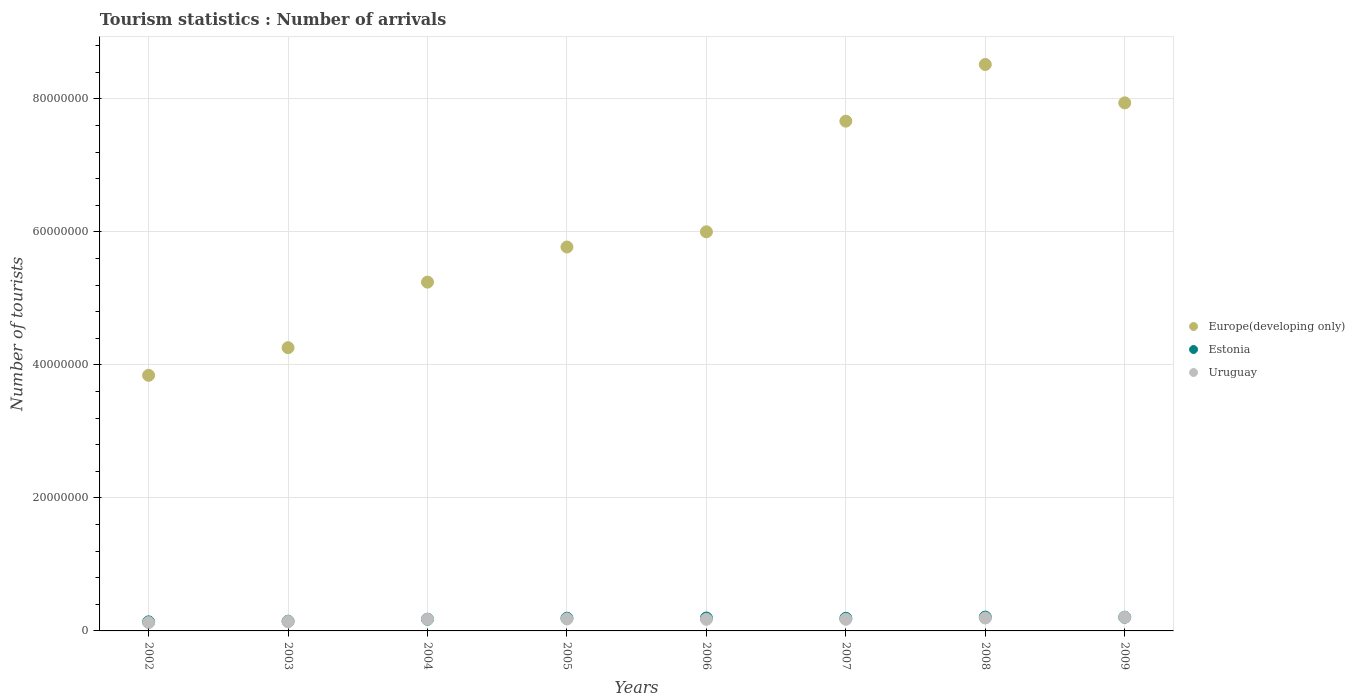Is the number of dotlines equal to the number of legend labels?
Give a very brief answer. Yes. What is the number of tourist arrivals in Estonia in 2003?
Ensure brevity in your answer.  1.46e+06. Across all years, what is the maximum number of tourist arrivals in Uruguay?
Offer a very short reply. 2.06e+06. Across all years, what is the minimum number of tourist arrivals in Europe(developing only)?
Your answer should be very brief. 3.84e+07. What is the total number of tourist arrivals in Europe(developing only) in the graph?
Your answer should be very brief. 4.92e+08. What is the difference between the number of tourist arrivals in Uruguay in 2002 and that in 2009?
Offer a terse response. -7.97e+05. What is the difference between the number of tourist arrivals in Estonia in 2004 and the number of tourist arrivals in Europe(developing only) in 2003?
Keep it short and to the point. -4.08e+07. What is the average number of tourist arrivals in Europe(developing only) per year?
Provide a succinct answer. 6.16e+07. In the year 2006, what is the difference between the number of tourist arrivals in Europe(developing only) and number of tourist arrivals in Uruguay?
Offer a terse response. 5.83e+07. What is the ratio of the number of tourist arrivals in Uruguay in 2004 to that in 2006?
Keep it short and to the point. 1. What is the difference between the highest and the second highest number of tourist arrivals in Uruguay?
Your answer should be compact. 1.17e+05. What is the difference between the highest and the lowest number of tourist arrivals in Europe(developing only)?
Make the answer very short. 4.67e+07. Is it the case that in every year, the sum of the number of tourist arrivals in Europe(developing only) and number of tourist arrivals in Uruguay  is greater than the number of tourist arrivals in Estonia?
Ensure brevity in your answer.  Yes. Does the number of tourist arrivals in Estonia monotonically increase over the years?
Keep it short and to the point. No. How many dotlines are there?
Your response must be concise. 3. What is the difference between two consecutive major ticks on the Y-axis?
Offer a terse response. 2.00e+07. Does the graph contain any zero values?
Your answer should be compact. No. How are the legend labels stacked?
Give a very brief answer. Vertical. What is the title of the graph?
Make the answer very short. Tourism statistics : Number of arrivals. What is the label or title of the Y-axis?
Offer a very short reply. Number of tourists. What is the Number of tourists in Europe(developing only) in 2002?
Offer a very short reply. 3.84e+07. What is the Number of tourists of Estonia in 2002?
Your response must be concise. 1.36e+06. What is the Number of tourists in Uruguay in 2002?
Your response must be concise. 1.26e+06. What is the Number of tourists of Europe(developing only) in 2003?
Provide a short and direct response. 4.26e+07. What is the Number of tourists in Estonia in 2003?
Keep it short and to the point. 1.46e+06. What is the Number of tourists of Uruguay in 2003?
Make the answer very short. 1.42e+06. What is the Number of tourists in Europe(developing only) in 2004?
Ensure brevity in your answer.  5.24e+07. What is the Number of tourists of Estonia in 2004?
Provide a short and direct response. 1.75e+06. What is the Number of tourists of Uruguay in 2004?
Give a very brief answer. 1.76e+06. What is the Number of tourists in Europe(developing only) in 2005?
Provide a succinct answer. 5.77e+07. What is the Number of tourists in Estonia in 2005?
Offer a very short reply. 1.92e+06. What is the Number of tourists of Uruguay in 2005?
Provide a short and direct response. 1.81e+06. What is the Number of tourists of Europe(developing only) in 2006?
Ensure brevity in your answer.  6.00e+07. What is the Number of tourists in Estonia in 2006?
Provide a succinct answer. 1.94e+06. What is the Number of tourists in Uruguay in 2006?
Ensure brevity in your answer.  1.75e+06. What is the Number of tourists in Europe(developing only) in 2007?
Offer a very short reply. 7.67e+07. What is the Number of tourists in Estonia in 2007?
Your answer should be very brief. 1.90e+06. What is the Number of tourists in Uruguay in 2007?
Offer a very short reply. 1.75e+06. What is the Number of tourists of Europe(developing only) in 2008?
Your response must be concise. 8.52e+07. What is the Number of tourists of Estonia in 2008?
Give a very brief answer. 2.08e+06. What is the Number of tourists in Uruguay in 2008?
Make the answer very short. 1.94e+06. What is the Number of tourists of Europe(developing only) in 2009?
Your response must be concise. 7.94e+07. What is the Number of tourists of Estonia in 2009?
Your answer should be compact. 2.06e+06. What is the Number of tourists in Uruguay in 2009?
Ensure brevity in your answer.  2.06e+06. Across all years, what is the maximum Number of tourists of Europe(developing only)?
Your answer should be compact. 8.52e+07. Across all years, what is the maximum Number of tourists of Estonia?
Provide a short and direct response. 2.08e+06. Across all years, what is the maximum Number of tourists of Uruguay?
Ensure brevity in your answer.  2.06e+06. Across all years, what is the minimum Number of tourists in Europe(developing only)?
Ensure brevity in your answer.  3.84e+07. Across all years, what is the minimum Number of tourists of Estonia?
Keep it short and to the point. 1.36e+06. Across all years, what is the minimum Number of tourists of Uruguay?
Provide a succinct answer. 1.26e+06. What is the total Number of tourists of Europe(developing only) in the graph?
Your answer should be very brief. 4.92e+08. What is the total Number of tourists of Estonia in the graph?
Your response must be concise. 1.45e+07. What is the total Number of tourists in Uruguay in the graph?
Offer a terse response. 1.37e+07. What is the difference between the Number of tourists in Europe(developing only) in 2002 and that in 2003?
Your answer should be very brief. -4.16e+06. What is the difference between the Number of tourists in Estonia in 2002 and that in 2003?
Offer a terse response. -1.00e+05. What is the difference between the Number of tourists of Uruguay in 2002 and that in 2003?
Ensure brevity in your answer.  -1.62e+05. What is the difference between the Number of tourists in Europe(developing only) in 2002 and that in 2004?
Give a very brief answer. -1.40e+07. What is the difference between the Number of tourists of Estonia in 2002 and that in 2004?
Give a very brief answer. -3.88e+05. What is the difference between the Number of tourists in Uruguay in 2002 and that in 2004?
Your answer should be compact. -4.98e+05. What is the difference between the Number of tourists of Europe(developing only) in 2002 and that in 2005?
Your response must be concise. -1.93e+07. What is the difference between the Number of tourists in Estonia in 2002 and that in 2005?
Offer a very short reply. -5.55e+05. What is the difference between the Number of tourists of Uruguay in 2002 and that in 2005?
Give a very brief answer. -5.50e+05. What is the difference between the Number of tourists in Europe(developing only) in 2002 and that in 2006?
Your response must be concise. -2.16e+07. What is the difference between the Number of tourists in Estonia in 2002 and that in 2006?
Provide a succinct answer. -5.78e+05. What is the difference between the Number of tourists of Uruguay in 2002 and that in 2006?
Your response must be concise. -4.91e+05. What is the difference between the Number of tourists of Europe(developing only) in 2002 and that in 2007?
Keep it short and to the point. -3.82e+07. What is the difference between the Number of tourists of Estonia in 2002 and that in 2007?
Provide a succinct answer. -5.38e+05. What is the difference between the Number of tourists in Uruguay in 2002 and that in 2007?
Offer a very short reply. -4.95e+05. What is the difference between the Number of tourists in Europe(developing only) in 2002 and that in 2008?
Provide a short and direct response. -4.67e+07. What is the difference between the Number of tourists in Estonia in 2002 and that in 2008?
Provide a short and direct response. -7.17e+05. What is the difference between the Number of tourists in Uruguay in 2002 and that in 2008?
Your answer should be compact. -6.80e+05. What is the difference between the Number of tourists in Europe(developing only) in 2002 and that in 2009?
Offer a very short reply. -4.10e+07. What is the difference between the Number of tourists in Estonia in 2002 and that in 2009?
Make the answer very short. -6.97e+05. What is the difference between the Number of tourists in Uruguay in 2002 and that in 2009?
Your answer should be very brief. -7.97e+05. What is the difference between the Number of tourists of Europe(developing only) in 2003 and that in 2004?
Offer a very short reply. -9.86e+06. What is the difference between the Number of tourists in Estonia in 2003 and that in 2004?
Keep it short and to the point. -2.88e+05. What is the difference between the Number of tourists of Uruguay in 2003 and that in 2004?
Offer a terse response. -3.36e+05. What is the difference between the Number of tourists in Europe(developing only) in 2003 and that in 2005?
Provide a succinct answer. -1.51e+07. What is the difference between the Number of tourists of Estonia in 2003 and that in 2005?
Your response must be concise. -4.55e+05. What is the difference between the Number of tourists in Uruguay in 2003 and that in 2005?
Provide a short and direct response. -3.88e+05. What is the difference between the Number of tourists in Europe(developing only) in 2003 and that in 2006?
Your response must be concise. -1.74e+07. What is the difference between the Number of tourists of Estonia in 2003 and that in 2006?
Provide a short and direct response. -4.78e+05. What is the difference between the Number of tourists in Uruguay in 2003 and that in 2006?
Your response must be concise. -3.29e+05. What is the difference between the Number of tourists of Europe(developing only) in 2003 and that in 2007?
Give a very brief answer. -3.41e+07. What is the difference between the Number of tourists of Estonia in 2003 and that in 2007?
Offer a very short reply. -4.38e+05. What is the difference between the Number of tourists in Uruguay in 2003 and that in 2007?
Your answer should be very brief. -3.33e+05. What is the difference between the Number of tourists in Europe(developing only) in 2003 and that in 2008?
Provide a succinct answer. -4.26e+07. What is the difference between the Number of tourists in Estonia in 2003 and that in 2008?
Offer a very short reply. -6.17e+05. What is the difference between the Number of tourists of Uruguay in 2003 and that in 2008?
Keep it short and to the point. -5.18e+05. What is the difference between the Number of tourists in Europe(developing only) in 2003 and that in 2009?
Provide a short and direct response. -3.68e+07. What is the difference between the Number of tourists in Estonia in 2003 and that in 2009?
Give a very brief answer. -5.97e+05. What is the difference between the Number of tourists in Uruguay in 2003 and that in 2009?
Provide a succinct answer. -6.35e+05. What is the difference between the Number of tourists in Europe(developing only) in 2004 and that in 2005?
Make the answer very short. -5.28e+06. What is the difference between the Number of tourists of Estonia in 2004 and that in 2005?
Offer a very short reply. -1.67e+05. What is the difference between the Number of tourists of Uruguay in 2004 and that in 2005?
Offer a very short reply. -5.20e+04. What is the difference between the Number of tourists of Europe(developing only) in 2004 and that in 2006?
Offer a terse response. -7.56e+06. What is the difference between the Number of tourists of Uruguay in 2004 and that in 2006?
Your answer should be compact. 7000. What is the difference between the Number of tourists of Europe(developing only) in 2004 and that in 2007?
Give a very brief answer. -2.42e+07. What is the difference between the Number of tourists in Uruguay in 2004 and that in 2007?
Provide a succinct answer. 3000. What is the difference between the Number of tourists of Europe(developing only) in 2004 and that in 2008?
Give a very brief answer. -3.27e+07. What is the difference between the Number of tourists of Estonia in 2004 and that in 2008?
Give a very brief answer. -3.29e+05. What is the difference between the Number of tourists in Uruguay in 2004 and that in 2008?
Give a very brief answer. -1.82e+05. What is the difference between the Number of tourists of Europe(developing only) in 2004 and that in 2009?
Your answer should be very brief. -2.70e+07. What is the difference between the Number of tourists in Estonia in 2004 and that in 2009?
Your response must be concise. -3.09e+05. What is the difference between the Number of tourists of Uruguay in 2004 and that in 2009?
Give a very brief answer. -2.99e+05. What is the difference between the Number of tourists in Europe(developing only) in 2005 and that in 2006?
Offer a terse response. -2.28e+06. What is the difference between the Number of tourists of Estonia in 2005 and that in 2006?
Keep it short and to the point. -2.30e+04. What is the difference between the Number of tourists in Uruguay in 2005 and that in 2006?
Your answer should be compact. 5.90e+04. What is the difference between the Number of tourists of Europe(developing only) in 2005 and that in 2007?
Offer a very short reply. -1.89e+07. What is the difference between the Number of tourists of Estonia in 2005 and that in 2007?
Make the answer very short. 1.70e+04. What is the difference between the Number of tourists of Uruguay in 2005 and that in 2007?
Provide a succinct answer. 5.50e+04. What is the difference between the Number of tourists of Europe(developing only) in 2005 and that in 2008?
Make the answer very short. -2.74e+07. What is the difference between the Number of tourists of Estonia in 2005 and that in 2008?
Give a very brief answer. -1.62e+05. What is the difference between the Number of tourists in Europe(developing only) in 2005 and that in 2009?
Your response must be concise. -2.17e+07. What is the difference between the Number of tourists in Estonia in 2005 and that in 2009?
Offer a very short reply. -1.42e+05. What is the difference between the Number of tourists of Uruguay in 2005 and that in 2009?
Offer a terse response. -2.47e+05. What is the difference between the Number of tourists of Europe(developing only) in 2006 and that in 2007?
Your answer should be very brief. -1.66e+07. What is the difference between the Number of tourists of Uruguay in 2006 and that in 2007?
Give a very brief answer. -4000. What is the difference between the Number of tourists in Europe(developing only) in 2006 and that in 2008?
Make the answer very short. -2.52e+07. What is the difference between the Number of tourists of Estonia in 2006 and that in 2008?
Provide a succinct answer. -1.39e+05. What is the difference between the Number of tourists in Uruguay in 2006 and that in 2008?
Provide a succinct answer. -1.89e+05. What is the difference between the Number of tourists in Europe(developing only) in 2006 and that in 2009?
Offer a very short reply. -1.94e+07. What is the difference between the Number of tourists in Estonia in 2006 and that in 2009?
Offer a terse response. -1.19e+05. What is the difference between the Number of tourists in Uruguay in 2006 and that in 2009?
Provide a short and direct response. -3.06e+05. What is the difference between the Number of tourists in Europe(developing only) in 2007 and that in 2008?
Offer a terse response. -8.52e+06. What is the difference between the Number of tourists in Estonia in 2007 and that in 2008?
Provide a succinct answer. -1.79e+05. What is the difference between the Number of tourists of Uruguay in 2007 and that in 2008?
Give a very brief answer. -1.85e+05. What is the difference between the Number of tourists in Europe(developing only) in 2007 and that in 2009?
Provide a succinct answer. -2.75e+06. What is the difference between the Number of tourists in Estonia in 2007 and that in 2009?
Your answer should be very brief. -1.59e+05. What is the difference between the Number of tourists in Uruguay in 2007 and that in 2009?
Offer a very short reply. -3.02e+05. What is the difference between the Number of tourists of Europe(developing only) in 2008 and that in 2009?
Provide a succinct answer. 5.77e+06. What is the difference between the Number of tourists of Estonia in 2008 and that in 2009?
Your response must be concise. 2.00e+04. What is the difference between the Number of tourists in Uruguay in 2008 and that in 2009?
Your answer should be very brief. -1.17e+05. What is the difference between the Number of tourists in Europe(developing only) in 2002 and the Number of tourists in Estonia in 2003?
Offer a very short reply. 3.70e+07. What is the difference between the Number of tourists of Europe(developing only) in 2002 and the Number of tourists of Uruguay in 2003?
Keep it short and to the point. 3.70e+07. What is the difference between the Number of tourists of Estonia in 2002 and the Number of tourists of Uruguay in 2003?
Offer a very short reply. -5.80e+04. What is the difference between the Number of tourists of Europe(developing only) in 2002 and the Number of tourists of Estonia in 2004?
Give a very brief answer. 3.67e+07. What is the difference between the Number of tourists in Europe(developing only) in 2002 and the Number of tourists in Uruguay in 2004?
Give a very brief answer. 3.67e+07. What is the difference between the Number of tourists in Estonia in 2002 and the Number of tourists in Uruguay in 2004?
Your answer should be compact. -3.94e+05. What is the difference between the Number of tourists in Europe(developing only) in 2002 and the Number of tourists in Estonia in 2005?
Provide a short and direct response. 3.65e+07. What is the difference between the Number of tourists in Europe(developing only) in 2002 and the Number of tourists in Uruguay in 2005?
Keep it short and to the point. 3.66e+07. What is the difference between the Number of tourists of Estonia in 2002 and the Number of tourists of Uruguay in 2005?
Ensure brevity in your answer.  -4.46e+05. What is the difference between the Number of tourists in Europe(developing only) in 2002 and the Number of tourists in Estonia in 2006?
Provide a succinct answer. 3.65e+07. What is the difference between the Number of tourists in Europe(developing only) in 2002 and the Number of tourists in Uruguay in 2006?
Your answer should be compact. 3.67e+07. What is the difference between the Number of tourists in Estonia in 2002 and the Number of tourists in Uruguay in 2006?
Your answer should be compact. -3.87e+05. What is the difference between the Number of tourists of Europe(developing only) in 2002 and the Number of tourists of Estonia in 2007?
Keep it short and to the point. 3.65e+07. What is the difference between the Number of tourists in Europe(developing only) in 2002 and the Number of tourists in Uruguay in 2007?
Make the answer very short. 3.67e+07. What is the difference between the Number of tourists of Estonia in 2002 and the Number of tourists of Uruguay in 2007?
Your response must be concise. -3.91e+05. What is the difference between the Number of tourists of Europe(developing only) in 2002 and the Number of tourists of Estonia in 2008?
Make the answer very short. 3.64e+07. What is the difference between the Number of tourists of Europe(developing only) in 2002 and the Number of tourists of Uruguay in 2008?
Give a very brief answer. 3.65e+07. What is the difference between the Number of tourists of Estonia in 2002 and the Number of tourists of Uruguay in 2008?
Make the answer very short. -5.76e+05. What is the difference between the Number of tourists of Europe(developing only) in 2002 and the Number of tourists of Estonia in 2009?
Provide a short and direct response. 3.64e+07. What is the difference between the Number of tourists of Europe(developing only) in 2002 and the Number of tourists of Uruguay in 2009?
Ensure brevity in your answer.  3.64e+07. What is the difference between the Number of tourists in Estonia in 2002 and the Number of tourists in Uruguay in 2009?
Offer a very short reply. -6.93e+05. What is the difference between the Number of tourists of Europe(developing only) in 2003 and the Number of tourists of Estonia in 2004?
Your answer should be very brief. 4.08e+07. What is the difference between the Number of tourists in Europe(developing only) in 2003 and the Number of tourists in Uruguay in 2004?
Your answer should be very brief. 4.08e+07. What is the difference between the Number of tourists in Estonia in 2003 and the Number of tourists in Uruguay in 2004?
Provide a short and direct response. -2.94e+05. What is the difference between the Number of tourists of Europe(developing only) in 2003 and the Number of tourists of Estonia in 2005?
Provide a succinct answer. 4.07e+07. What is the difference between the Number of tourists in Europe(developing only) in 2003 and the Number of tourists in Uruguay in 2005?
Offer a very short reply. 4.08e+07. What is the difference between the Number of tourists in Estonia in 2003 and the Number of tourists in Uruguay in 2005?
Your answer should be compact. -3.46e+05. What is the difference between the Number of tourists of Europe(developing only) in 2003 and the Number of tourists of Estonia in 2006?
Keep it short and to the point. 4.06e+07. What is the difference between the Number of tourists of Europe(developing only) in 2003 and the Number of tourists of Uruguay in 2006?
Your answer should be very brief. 4.08e+07. What is the difference between the Number of tourists of Estonia in 2003 and the Number of tourists of Uruguay in 2006?
Offer a very short reply. -2.87e+05. What is the difference between the Number of tourists of Europe(developing only) in 2003 and the Number of tourists of Estonia in 2007?
Ensure brevity in your answer.  4.07e+07. What is the difference between the Number of tourists in Europe(developing only) in 2003 and the Number of tourists in Uruguay in 2007?
Your answer should be compact. 4.08e+07. What is the difference between the Number of tourists of Estonia in 2003 and the Number of tourists of Uruguay in 2007?
Make the answer very short. -2.91e+05. What is the difference between the Number of tourists of Europe(developing only) in 2003 and the Number of tourists of Estonia in 2008?
Offer a very short reply. 4.05e+07. What is the difference between the Number of tourists of Europe(developing only) in 2003 and the Number of tourists of Uruguay in 2008?
Offer a very short reply. 4.07e+07. What is the difference between the Number of tourists of Estonia in 2003 and the Number of tourists of Uruguay in 2008?
Provide a succinct answer. -4.76e+05. What is the difference between the Number of tourists in Europe(developing only) in 2003 and the Number of tourists in Estonia in 2009?
Ensure brevity in your answer.  4.05e+07. What is the difference between the Number of tourists in Europe(developing only) in 2003 and the Number of tourists in Uruguay in 2009?
Your response must be concise. 4.05e+07. What is the difference between the Number of tourists in Estonia in 2003 and the Number of tourists in Uruguay in 2009?
Provide a succinct answer. -5.93e+05. What is the difference between the Number of tourists in Europe(developing only) in 2004 and the Number of tourists in Estonia in 2005?
Your response must be concise. 5.05e+07. What is the difference between the Number of tourists of Europe(developing only) in 2004 and the Number of tourists of Uruguay in 2005?
Your answer should be very brief. 5.06e+07. What is the difference between the Number of tourists in Estonia in 2004 and the Number of tourists in Uruguay in 2005?
Your response must be concise. -5.80e+04. What is the difference between the Number of tourists of Europe(developing only) in 2004 and the Number of tourists of Estonia in 2006?
Your answer should be very brief. 5.05e+07. What is the difference between the Number of tourists of Europe(developing only) in 2004 and the Number of tourists of Uruguay in 2006?
Give a very brief answer. 5.07e+07. What is the difference between the Number of tourists in Estonia in 2004 and the Number of tourists in Uruguay in 2006?
Offer a very short reply. 1000. What is the difference between the Number of tourists of Europe(developing only) in 2004 and the Number of tourists of Estonia in 2007?
Keep it short and to the point. 5.05e+07. What is the difference between the Number of tourists of Europe(developing only) in 2004 and the Number of tourists of Uruguay in 2007?
Give a very brief answer. 5.07e+07. What is the difference between the Number of tourists of Estonia in 2004 and the Number of tourists of Uruguay in 2007?
Ensure brevity in your answer.  -3000. What is the difference between the Number of tourists of Europe(developing only) in 2004 and the Number of tourists of Estonia in 2008?
Make the answer very short. 5.04e+07. What is the difference between the Number of tourists in Europe(developing only) in 2004 and the Number of tourists in Uruguay in 2008?
Provide a short and direct response. 5.05e+07. What is the difference between the Number of tourists of Estonia in 2004 and the Number of tourists of Uruguay in 2008?
Your answer should be very brief. -1.88e+05. What is the difference between the Number of tourists in Europe(developing only) in 2004 and the Number of tourists in Estonia in 2009?
Provide a short and direct response. 5.04e+07. What is the difference between the Number of tourists of Europe(developing only) in 2004 and the Number of tourists of Uruguay in 2009?
Keep it short and to the point. 5.04e+07. What is the difference between the Number of tourists of Estonia in 2004 and the Number of tourists of Uruguay in 2009?
Make the answer very short. -3.05e+05. What is the difference between the Number of tourists in Europe(developing only) in 2005 and the Number of tourists in Estonia in 2006?
Offer a terse response. 5.58e+07. What is the difference between the Number of tourists in Europe(developing only) in 2005 and the Number of tourists in Uruguay in 2006?
Your answer should be compact. 5.60e+07. What is the difference between the Number of tourists in Estonia in 2005 and the Number of tourists in Uruguay in 2006?
Keep it short and to the point. 1.68e+05. What is the difference between the Number of tourists of Europe(developing only) in 2005 and the Number of tourists of Estonia in 2007?
Offer a terse response. 5.58e+07. What is the difference between the Number of tourists of Europe(developing only) in 2005 and the Number of tourists of Uruguay in 2007?
Make the answer very short. 5.60e+07. What is the difference between the Number of tourists of Estonia in 2005 and the Number of tourists of Uruguay in 2007?
Your answer should be very brief. 1.64e+05. What is the difference between the Number of tourists in Europe(developing only) in 2005 and the Number of tourists in Estonia in 2008?
Make the answer very short. 5.57e+07. What is the difference between the Number of tourists in Europe(developing only) in 2005 and the Number of tourists in Uruguay in 2008?
Make the answer very short. 5.58e+07. What is the difference between the Number of tourists of Estonia in 2005 and the Number of tourists of Uruguay in 2008?
Your response must be concise. -2.10e+04. What is the difference between the Number of tourists in Europe(developing only) in 2005 and the Number of tourists in Estonia in 2009?
Keep it short and to the point. 5.57e+07. What is the difference between the Number of tourists in Europe(developing only) in 2005 and the Number of tourists in Uruguay in 2009?
Offer a very short reply. 5.57e+07. What is the difference between the Number of tourists of Estonia in 2005 and the Number of tourists of Uruguay in 2009?
Keep it short and to the point. -1.38e+05. What is the difference between the Number of tourists of Europe(developing only) in 2006 and the Number of tourists of Estonia in 2007?
Provide a short and direct response. 5.81e+07. What is the difference between the Number of tourists in Europe(developing only) in 2006 and the Number of tourists in Uruguay in 2007?
Provide a short and direct response. 5.83e+07. What is the difference between the Number of tourists of Estonia in 2006 and the Number of tourists of Uruguay in 2007?
Give a very brief answer. 1.87e+05. What is the difference between the Number of tourists in Europe(developing only) in 2006 and the Number of tourists in Estonia in 2008?
Ensure brevity in your answer.  5.79e+07. What is the difference between the Number of tourists of Europe(developing only) in 2006 and the Number of tourists of Uruguay in 2008?
Offer a terse response. 5.81e+07. What is the difference between the Number of tourists in Estonia in 2006 and the Number of tourists in Uruguay in 2008?
Offer a very short reply. 2000. What is the difference between the Number of tourists of Europe(developing only) in 2006 and the Number of tourists of Estonia in 2009?
Give a very brief answer. 5.80e+07. What is the difference between the Number of tourists in Europe(developing only) in 2006 and the Number of tourists in Uruguay in 2009?
Keep it short and to the point. 5.80e+07. What is the difference between the Number of tourists in Estonia in 2006 and the Number of tourists in Uruguay in 2009?
Your answer should be very brief. -1.15e+05. What is the difference between the Number of tourists of Europe(developing only) in 2007 and the Number of tourists of Estonia in 2008?
Give a very brief answer. 7.46e+07. What is the difference between the Number of tourists of Europe(developing only) in 2007 and the Number of tourists of Uruguay in 2008?
Offer a very short reply. 7.47e+07. What is the difference between the Number of tourists in Estonia in 2007 and the Number of tourists in Uruguay in 2008?
Your answer should be compact. -3.80e+04. What is the difference between the Number of tourists of Europe(developing only) in 2007 and the Number of tourists of Estonia in 2009?
Offer a very short reply. 7.46e+07. What is the difference between the Number of tourists in Europe(developing only) in 2007 and the Number of tourists in Uruguay in 2009?
Ensure brevity in your answer.  7.46e+07. What is the difference between the Number of tourists in Estonia in 2007 and the Number of tourists in Uruguay in 2009?
Ensure brevity in your answer.  -1.55e+05. What is the difference between the Number of tourists of Europe(developing only) in 2008 and the Number of tourists of Estonia in 2009?
Offer a terse response. 8.31e+07. What is the difference between the Number of tourists in Europe(developing only) in 2008 and the Number of tourists in Uruguay in 2009?
Your response must be concise. 8.31e+07. What is the difference between the Number of tourists in Estonia in 2008 and the Number of tourists in Uruguay in 2009?
Your answer should be very brief. 2.40e+04. What is the average Number of tourists of Europe(developing only) per year?
Your answer should be very brief. 6.16e+07. What is the average Number of tourists of Estonia per year?
Make the answer very short. 1.81e+06. What is the average Number of tourists of Uruguay per year?
Make the answer very short. 1.72e+06. In the year 2002, what is the difference between the Number of tourists in Europe(developing only) and Number of tourists in Estonia?
Offer a very short reply. 3.71e+07. In the year 2002, what is the difference between the Number of tourists of Europe(developing only) and Number of tourists of Uruguay?
Your answer should be very brief. 3.72e+07. In the year 2002, what is the difference between the Number of tourists of Estonia and Number of tourists of Uruguay?
Give a very brief answer. 1.04e+05. In the year 2003, what is the difference between the Number of tourists in Europe(developing only) and Number of tourists in Estonia?
Offer a terse response. 4.11e+07. In the year 2003, what is the difference between the Number of tourists in Europe(developing only) and Number of tourists in Uruguay?
Keep it short and to the point. 4.12e+07. In the year 2003, what is the difference between the Number of tourists in Estonia and Number of tourists in Uruguay?
Offer a very short reply. 4.20e+04. In the year 2004, what is the difference between the Number of tourists of Europe(developing only) and Number of tourists of Estonia?
Offer a very short reply. 5.07e+07. In the year 2004, what is the difference between the Number of tourists of Europe(developing only) and Number of tourists of Uruguay?
Your answer should be very brief. 5.07e+07. In the year 2004, what is the difference between the Number of tourists in Estonia and Number of tourists in Uruguay?
Give a very brief answer. -6000. In the year 2005, what is the difference between the Number of tourists of Europe(developing only) and Number of tourists of Estonia?
Offer a terse response. 5.58e+07. In the year 2005, what is the difference between the Number of tourists of Europe(developing only) and Number of tourists of Uruguay?
Your answer should be very brief. 5.59e+07. In the year 2005, what is the difference between the Number of tourists in Estonia and Number of tourists in Uruguay?
Your answer should be very brief. 1.09e+05. In the year 2006, what is the difference between the Number of tourists of Europe(developing only) and Number of tourists of Estonia?
Provide a succinct answer. 5.81e+07. In the year 2006, what is the difference between the Number of tourists in Europe(developing only) and Number of tourists in Uruguay?
Provide a succinct answer. 5.83e+07. In the year 2006, what is the difference between the Number of tourists in Estonia and Number of tourists in Uruguay?
Keep it short and to the point. 1.91e+05. In the year 2007, what is the difference between the Number of tourists in Europe(developing only) and Number of tourists in Estonia?
Offer a very short reply. 7.48e+07. In the year 2007, what is the difference between the Number of tourists in Europe(developing only) and Number of tourists in Uruguay?
Ensure brevity in your answer.  7.49e+07. In the year 2007, what is the difference between the Number of tourists of Estonia and Number of tourists of Uruguay?
Keep it short and to the point. 1.47e+05. In the year 2008, what is the difference between the Number of tourists of Europe(developing only) and Number of tourists of Estonia?
Offer a very short reply. 8.31e+07. In the year 2008, what is the difference between the Number of tourists of Europe(developing only) and Number of tourists of Uruguay?
Ensure brevity in your answer.  8.32e+07. In the year 2008, what is the difference between the Number of tourists in Estonia and Number of tourists in Uruguay?
Your answer should be compact. 1.41e+05. In the year 2009, what is the difference between the Number of tourists of Europe(developing only) and Number of tourists of Estonia?
Ensure brevity in your answer.  7.73e+07. In the year 2009, what is the difference between the Number of tourists of Europe(developing only) and Number of tourists of Uruguay?
Your answer should be compact. 7.73e+07. In the year 2009, what is the difference between the Number of tourists of Estonia and Number of tourists of Uruguay?
Offer a terse response. 4000. What is the ratio of the Number of tourists in Europe(developing only) in 2002 to that in 2003?
Give a very brief answer. 0.9. What is the ratio of the Number of tourists of Estonia in 2002 to that in 2003?
Offer a terse response. 0.93. What is the ratio of the Number of tourists of Uruguay in 2002 to that in 2003?
Your answer should be compact. 0.89. What is the ratio of the Number of tourists of Europe(developing only) in 2002 to that in 2004?
Keep it short and to the point. 0.73. What is the ratio of the Number of tourists in Estonia in 2002 to that in 2004?
Keep it short and to the point. 0.78. What is the ratio of the Number of tourists in Uruguay in 2002 to that in 2004?
Offer a very short reply. 0.72. What is the ratio of the Number of tourists in Europe(developing only) in 2002 to that in 2005?
Make the answer very short. 0.67. What is the ratio of the Number of tourists of Estonia in 2002 to that in 2005?
Ensure brevity in your answer.  0.71. What is the ratio of the Number of tourists in Uruguay in 2002 to that in 2005?
Keep it short and to the point. 0.7. What is the ratio of the Number of tourists in Europe(developing only) in 2002 to that in 2006?
Give a very brief answer. 0.64. What is the ratio of the Number of tourists of Estonia in 2002 to that in 2006?
Give a very brief answer. 0.7. What is the ratio of the Number of tourists of Uruguay in 2002 to that in 2006?
Make the answer very short. 0.72. What is the ratio of the Number of tourists in Europe(developing only) in 2002 to that in 2007?
Offer a terse response. 0.5. What is the ratio of the Number of tourists of Estonia in 2002 to that in 2007?
Offer a very short reply. 0.72. What is the ratio of the Number of tourists in Uruguay in 2002 to that in 2007?
Keep it short and to the point. 0.72. What is the ratio of the Number of tourists of Europe(developing only) in 2002 to that in 2008?
Provide a short and direct response. 0.45. What is the ratio of the Number of tourists of Estonia in 2002 to that in 2008?
Make the answer very short. 0.66. What is the ratio of the Number of tourists in Uruguay in 2002 to that in 2008?
Make the answer very short. 0.65. What is the ratio of the Number of tourists in Europe(developing only) in 2002 to that in 2009?
Provide a succinct answer. 0.48. What is the ratio of the Number of tourists in Estonia in 2002 to that in 2009?
Provide a succinct answer. 0.66. What is the ratio of the Number of tourists of Uruguay in 2002 to that in 2009?
Your answer should be compact. 0.61. What is the ratio of the Number of tourists of Europe(developing only) in 2003 to that in 2004?
Your answer should be compact. 0.81. What is the ratio of the Number of tourists in Estonia in 2003 to that in 2004?
Ensure brevity in your answer.  0.84. What is the ratio of the Number of tourists of Uruguay in 2003 to that in 2004?
Offer a very short reply. 0.81. What is the ratio of the Number of tourists in Europe(developing only) in 2003 to that in 2005?
Your answer should be very brief. 0.74. What is the ratio of the Number of tourists in Estonia in 2003 to that in 2005?
Keep it short and to the point. 0.76. What is the ratio of the Number of tourists in Uruguay in 2003 to that in 2005?
Provide a succinct answer. 0.79. What is the ratio of the Number of tourists of Europe(developing only) in 2003 to that in 2006?
Give a very brief answer. 0.71. What is the ratio of the Number of tourists of Estonia in 2003 to that in 2006?
Provide a succinct answer. 0.75. What is the ratio of the Number of tourists of Uruguay in 2003 to that in 2006?
Your answer should be compact. 0.81. What is the ratio of the Number of tourists in Europe(developing only) in 2003 to that in 2007?
Ensure brevity in your answer.  0.56. What is the ratio of the Number of tourists in Estonia in 2003 to that in 2007?
Give a very brief answer. 0.77. What is the ratio of the Number of tourists in Uruguay in 2003 to that in 2007?
Your answer should be very brief. 0.81. What is the ratio of the Number of tourists in Europe(developing only) in 2003 to that in 2008?
Provide a short and direct response. 0.5. What is the ratio of the Number of tourists of Estonia in 2003 to that in 2008?
Your response must be concise. 0.7. What is the ratio of the Number of tourists of Uruguay in 2003 to that in 2008?
Ensure brevity in your answer.  0.73. What is the ratio of the Number of tourists of Europe(developing only) in 2003 to that in 2009?
Offer a very short reply. 0.54. What is the ratio of the Number of tourists of Estonia in 2003 to that in 2009?
Your answer should be compact. 0.71. What is the ratio of the Number of tourists in Uruguay in 2003 to that in 2009?
Provide a short and direct response. 0.69. What is the ratio of the Number of tourists in Europe(developing only) in 2004 to that in 2005?
Offer a terse response. 0.91. What is the ratio of the Number of tourists in Estonia in 2004 to that in 2005?
Ensure brevity in your answer.  0.91. What is the ratio of the Number of tourists of Uruguay in 2004 to that in 2005?
Your response must be concise. 0.97. What is the ratio of the Number of tourists in Europe(developing only) in 2004 to that in 2006?
Your answer should be very brief. 0.87. What is the ratio of the Number of tourists of Estonia in 2004 to that in 2006?
Offer a terse response. 0.9. What is the ratio of the Number of tourists of Europe(developing only) in 2004 to that in 2007?
Provide a succinct answer. 0.68. What is the ratio of the Number of tourists of Estonia in 2004 to that in 2007?
Your answer should be very brief. 0.92. What is the ratio of the Number of tourists of Europe(developing only) in 2004 to that in 2008?
Your response must be concise. 0.62. What is the ratio of the Number of tourists of Estonia in 2004 to that in 2008?
Offer a very short reply. 0.84. What is the ratio of the Number of tourists in Uruguay in 2004 to that in 2008?
Keep it short and to the point. 0.91. What is the ratio of the Number of tourists of Europe(developing only) in 2004 to that in 2009?
Offer a very short reply. 0.66. What is the ratio of the Number of tourists of Estonia in 2004 to that in 2009?
Make the answer very short. 0.85. What is the ratio of the Number of tourists of Uruguay in 2004 to that in 2009?
Provide a succinct answer. 0.85. What is the ratio of the Number of tourists of Europe(developing only) in 2005 to that in 2006?
Provide a short and direct response. 0.96. What is the ratio of the Number of tourists in Estonia in 2005 to that in 2006?
Ensure brevity in your answer.  0.99. What is the ratio of the Number of tourists in Uruguay in 2005 to that in 2006?
Give a very brief answer. 1.03. What is the ratio of the Number of tourists of Europe(developing only) in 2005 to that in 2007?
Provide a short and direct response. 0.75. What is the ratio of the Number of tourists in Estonia in 2005 to that in 2007?
Ensure brevity in your answer.  1.01. What is the ratio of the Number of tourists of Uruguay in 2005 to that in 2007?
Provide a short and direct response. 1.03. What is the ratio of the Number of tourists in Europe(developing only) in 2005 to that in 2008?
Give a very brief answer. 0.68. What is the ratio of the Number of tourists of Estonia in 2005 to that in 2008?
Provide a succinct answer. 0.92. What is the ratio of the Number of tourists in Uruguay in 2005 to that in 2008?
Provide a succinct answer. 0.93. What is the ratio of the Number of tourists of Europe(developing only) in 2005 to that in 2009?
Provide a succinct answer. 0.73. What is the ratio of the Number of tourists of Estonia in 2005 to that in 2009?
Keep it short and to the point. 0.93. What is the ratio of the Number of tourists of Uruguay in 2005 to that in 2009?
Your answer should be very brief. 0.88. What is the ratio of the Number of tourists in Europe(developing only) in 2006 to that in 2007?
Offer a terse response. 0.78. What is the ratio of the Number of tourists in Estonia in 2006 to that in 2007?
Keep it short and to the point. 1.02. What is the ratio of the Number of tourists in Uruguay in 2006 to that in 2007?
Provide a short and direct response. 1. What is the ratio of the Number of tourists in Europe(developing only) in 2006 to that in 2008?
Give a very brief answer. 0.7. What is the ratio of the Number of tourists in Estonia in 2006 to that in 2008?
Make the answer very short. 0.93. What is the ratio of the Number of tourists in Uruguay in 2006 to that in 2008?
Provide a succinct answer. 0.9. What is the ratio of the Number of tourists in Europe(developing only) in 2006 to that in 2009?
Give a very brief answer. 0.76. What is the ratio of the Number of tourists in Estonia in 2006 to that in 2009?
Give a very brief answer. 0.94. What is the ratio of the Number of tourists of Uruguay in 2006 to that in 2009?
Your answer should be compact. 0.85. What is the ratio of the Number of tourists of Europe(developing only) in 2007 to that in 2008?
Keep it short and to the point. 0.9. What is the ratio of the Number of tourists of Estonia in 2007 to that in 2008?
Keep it short and to the point. 0.91. What is the ratio of the Number of tourists of Uruguay in 2007 to that in 2008?
Your answer should be very brief. 0.9. What is the ratio of the Number of tourists in Europe(developing only) in 2007 to that in 2009?
Make the answer very short. 0.97. What is the ratio of the Number of tourists of Estonia in 2007 to that in 2009?
Provide a short and direct response. 0.92. What is the ratio of the Number of tourists in Uruguay in 2007 to that in 2009?
Ensure brevity in your answer.  0.85. What is the ratio of the Number of tourists in Europe(developing only) in 2008 to that in 2009?
Ensure brevity in your answer.  1.07. What is the ratio of the Number of tourists in Estonia in 2008 to that in 2009?
Offer a terse response. 1.01. What is the ratio of the Number of tourists of Uruguay in 2008 to that in 2009?
Offer a very short reply. 0.94. What is the difference between the highest and the second highest Number of tourists of Europe(developing only)?
Your response must be concise. 5.77e+06. What is the difference between the highest and the second highest Number of tourists in Estonia?
Your answer should be very brief. 2.00e+04. What is the difference between the highest and the second highest Number of tourists in Uruguay?
Ensure brevity in your answer.  1.17e+05. What is the difference between the highest and the lowest Number of tourists in Europe(developing only)?
Make the answer very short. 4.67e+07. What is the difference between the highest and the lowest Number of tourists of Estonia?
Your answer should be compact. 7.17e+05. What is the difference between the highest and the lowest Number of tourists in Uruguay?
Ensure brevity in your answer.  7.97e+05. 